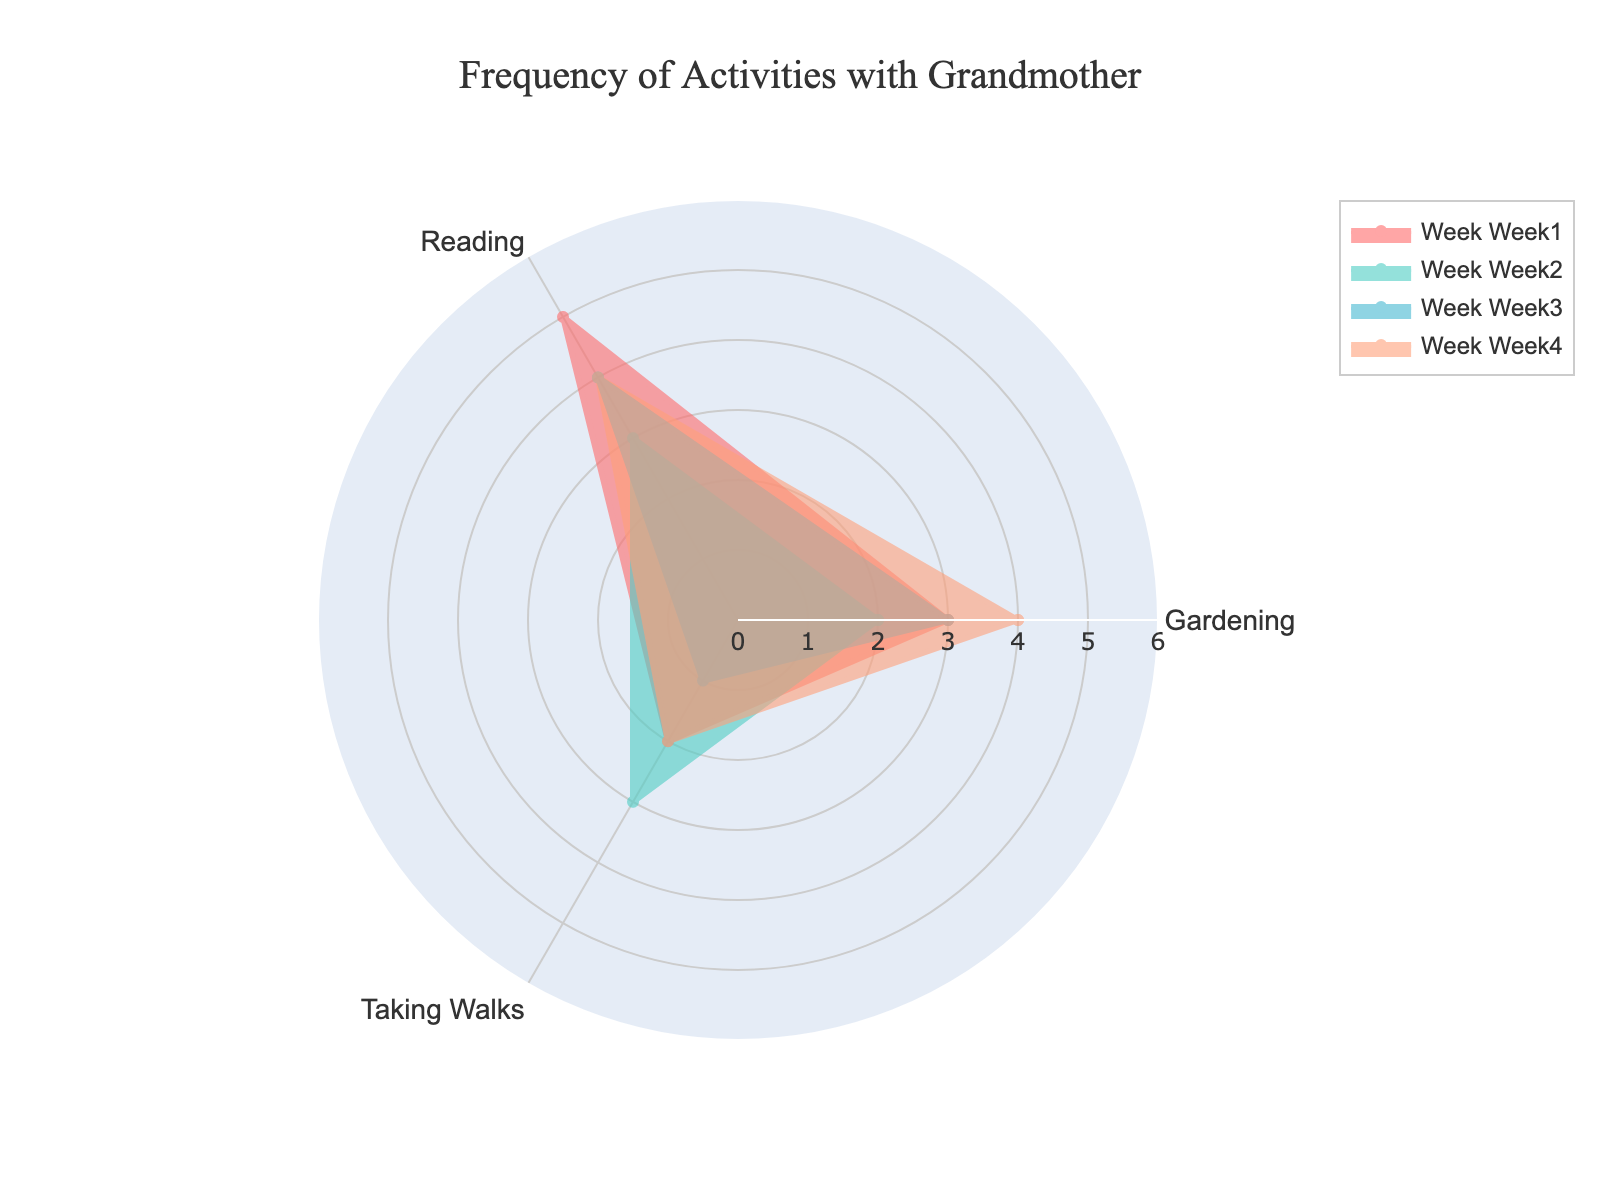What activities are represented in the radar chart? The radar chart has labeled axes for various activities performed with the grandmother. These labeled activities are obtained from the data categories in the dataset.
Answer: Gardening, Reading, Taking Walks What is the title of the radar chart? The title is shown prominently at the top of the chart in larger and bolded font.
Answer: Frequency of Activities with Grandmother Which week has the highest frequency for Gardening? By observing the values for each week around the Gardening axis, we see which week reaches the furthest.
Answer: Week 4 Over which range does the radial axis span? The radial axis is labeled with its range values, visible on the chart. It indicates the minimum and maximum possible frequencies.
Answer: 0 to 6 How many weeks of data are being compared? The legend, located typically at the right or bottom side, lists the various weeks being compared.
Answer: 4 Which activity saw the largest drop in frequency from Week 1 to Week 3? Compare the values between Week 1 and Week 3 for each activity. Subtract Week 3 values from Week 1 values and find the largest decrement.
Answer: Taking Walks On average, which activity had the highest frequency over the four weeks? Calculate the average frequency for each activity over the four weeks. Compare the averages to find the highest one.
Answer: Reading Which activities’ frequencies approach at least 5 in any of the weeks? Check each activity's value for every week and see if any values are close to or reach 5 on the radial axis.
Answer: Reading Which activity trend shows the most consistency across the weeks? Consistency can be observed by looking at how line progressions are closer to each other on the chart. The lines that show the least variation represent consistency.
Answer: Reading Which activity had the lowest frequency in Week 2? Observe the values of all activities during Week 2 and identify the smallest value amongst them.
Answer: Gardening 